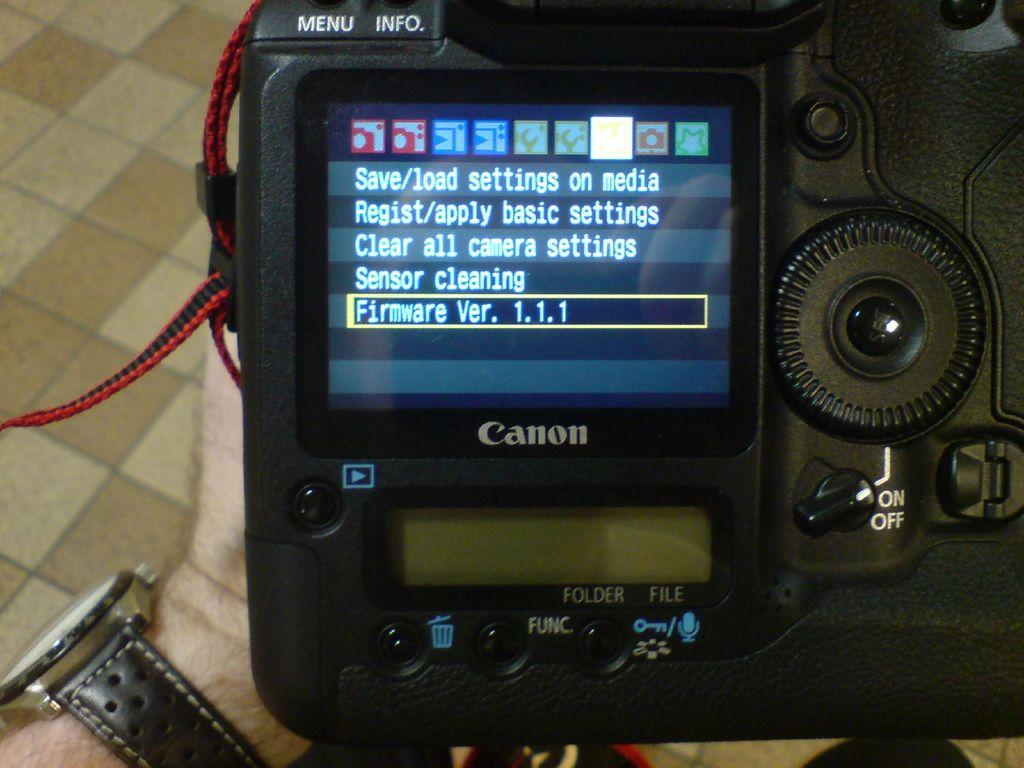<image>
Summarize the visual content of the image. A canon camera displays the firmware version it is using. 